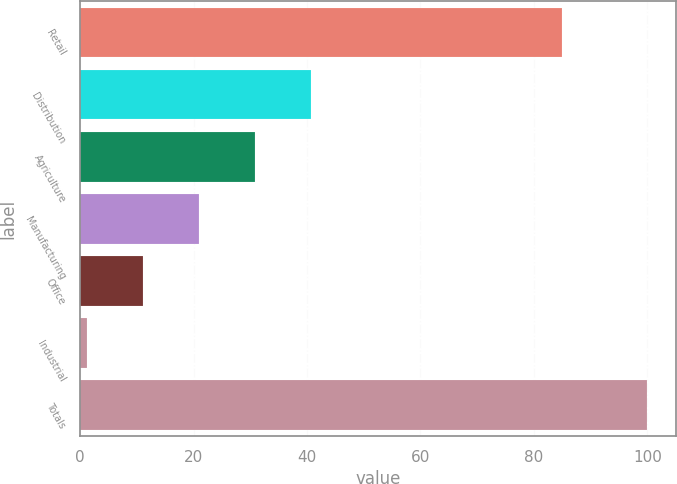<chart> <loc_0><loc_0><loc_500><loc_500><bar_chart><fcel>Retail<fcel>Distribution<fcel>Agriculture<fcel>Manufacturing<fcel>Office<fcel>Industrial<fcel>Totals<nl><fcel>84.9<fcel>40.72<fcel>30.84<fcel>20.96<fcel>11.08<fcel>1.2<fcel>100<nl></chart> 